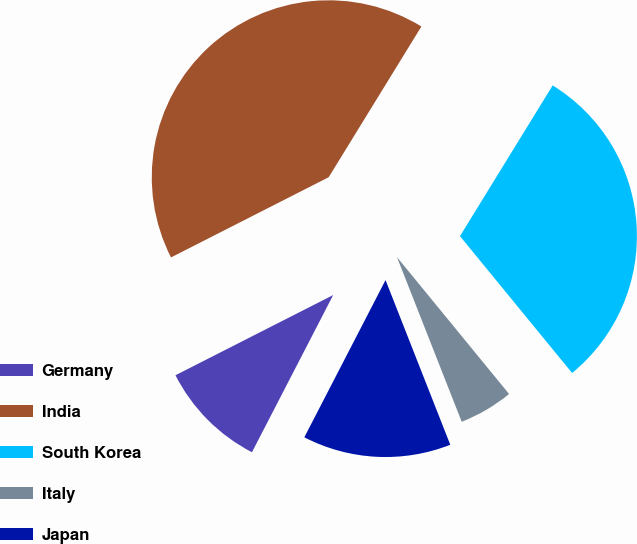Convert chart. <chart><loc_0><loc_0><loc_500><loc_500><pie_chart><fcel>Germany<fcel>India<fcel>South Korea<fcel>Italy<fcel>Japan<nl><fcel>9.92%<fcel>41.26%<fcel>30.3%<fcel>4.96%<fcel>13.55%<nl></chart> 